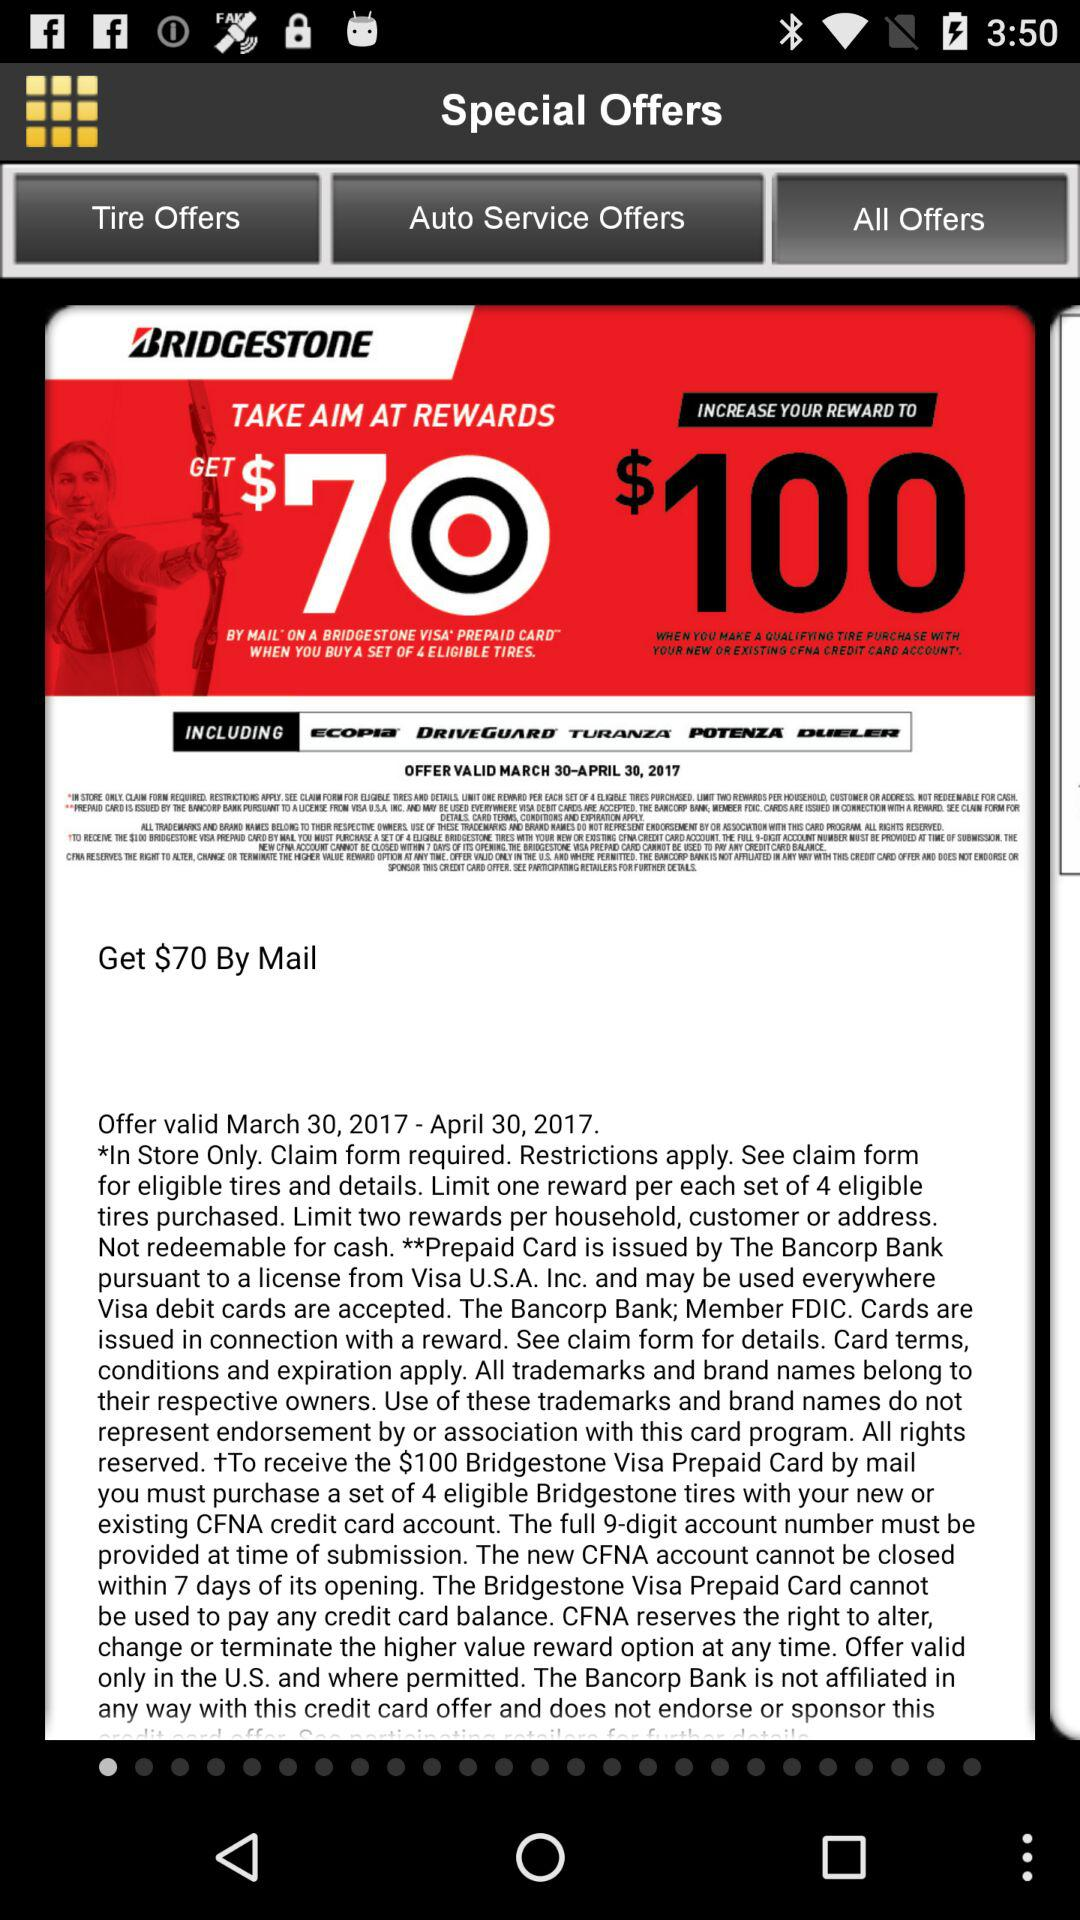How much more is the reward if you buy a set of 4 eligible tires?
Answer the question using a single word or phrase. $30 